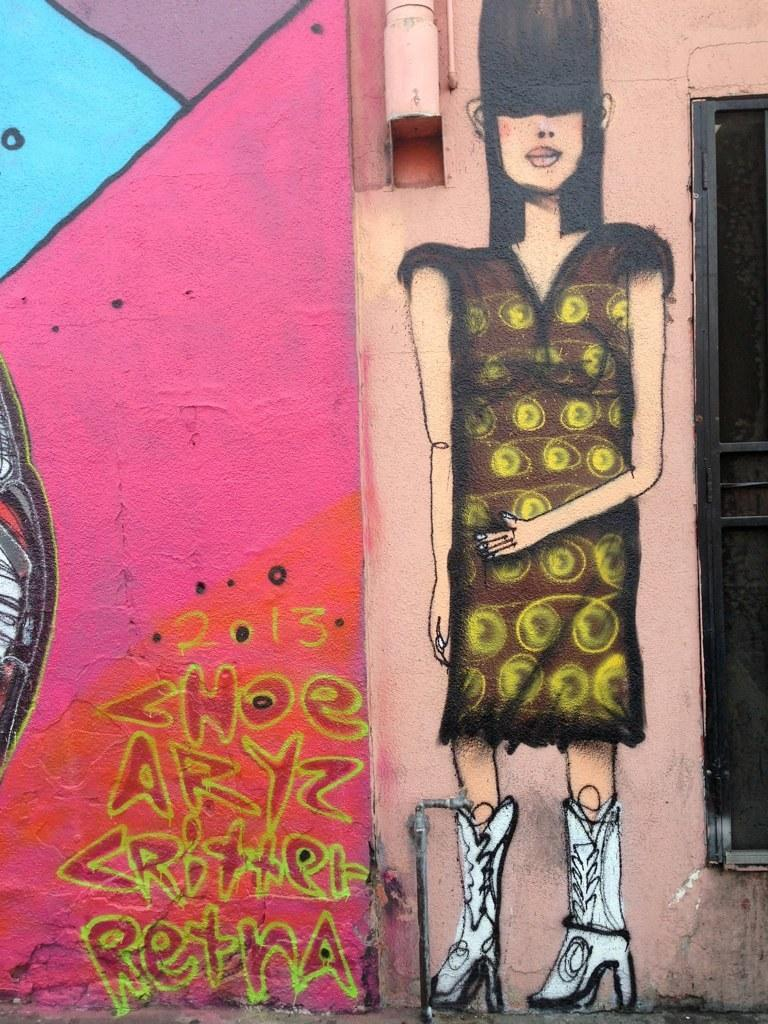What is the main subject of the image? There is a painting in the image. What does the painting depict? The painting depicts a woman. What is the woman doing in the painting? The woman is standing in the painting. What type of footwear is the woman wearing in the painting? The woman is wearing boots in the painting. How is the wall in the image decorated? The wall in the image is colorfully painted. How many men are depicted in the painting? There are no men depicted in the painting; it features a woman. Is there a letter visible in the painting? There is no letter present in the painting; it depicts a woman standing and wearing boots. 